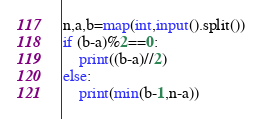Convert code to text. <code><loc_0><loc_0><loc_500><loc_500><_Python_>n,a,b=map(int,input().split())
if (b-a)%2==0:
    print((b-a)//2)
else:
    print(min(b-1,n-a))</code> 